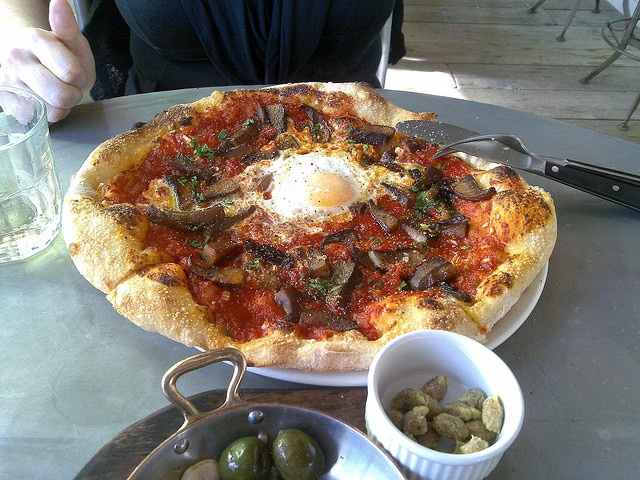Describe the objects in this image and their specific colors. I can see dining table in ivory, gray, darkgray, and maroon tones, pizza in ivory, maroon, and brown tones, people in ivory, black, white, gray, and darkgray tones, bowl in ivory, white, gray, darkgray, and darkgreen tones, and cup in ivory, white, lightblue, darkgray, and beige tones in this image. 